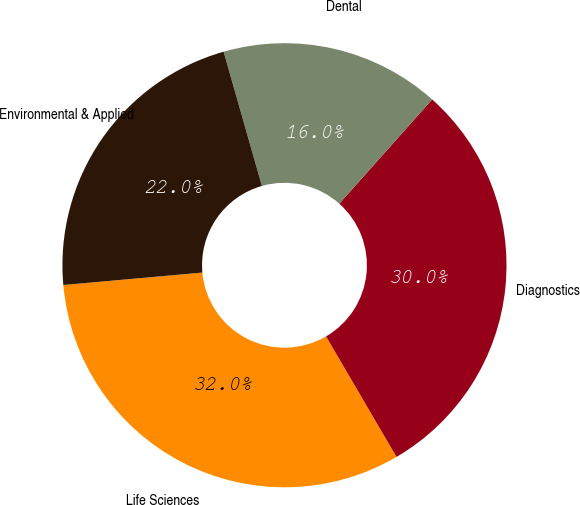<chart> <loc_0><loc_0><loc_500><loc_500><pie_chart><fcel>Life Sciences<fcel>Diagnostics<fcel>Dental<fcel>Environmental & Applied<nl><fcel>32.0%<fcel>30.0%<fcel>16.0%<fcel>22.0%<nl></chart> 